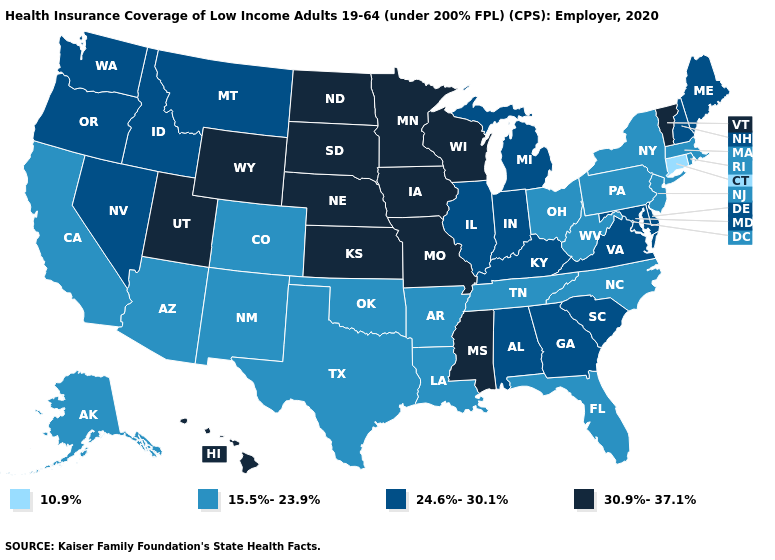Name the states that have a value in the range 15.5%-23.9%?
Quick response, please. Alaska, Arizona, Arkansas, California, Colorado, Florida, Louisiana, Massachusetts, New Jersey, New Mexico, New York, North Carolina, Ohio, Oklahoma, Pennsylvania, Rhode Island, Tennessee, Texas, West Virginia. Among the states that border Arkansas , does Texas have the highest value?
Quick response, please. No. Does Pennsylvania have the lowest value in the Northeast?
Concise answer only. No. What is the value of Alaska?
Write a very short answer. 15.5%-23.9%. What is the lowest value in the Northeast?
Quick response, please. 10.9%. Does the map have missing data?
Be succinct. No. Does Missouri have the highest value in the MidWest?
Keep it brief. Yes. Name the states that have a value in the range 30.9%-37.1%?
Quick response, please. Hawaii, Iowa, Kansas, Minnesota, Mississippi, Missouri, Nebraska, North Dakota, South Dakota, Utah, Vermont, Wisconsin, Wyoming. What is the lowest value in states that border Connecticut?
Give a very brief answer. 15.5%-23.9%. Name the states that have a value in the range 24.6%-30.1%?
Write a very short answer. Alabama, Delaware, Georgia, Idaho, Illinois, Indiana, Kentucky, Maine, Maryland, Michigan, Montana, Nevada, New Hampshire, Oregon, South Carolina, Virginia, Washington. Name the states that have a value in the range 15.5%-23.9%?
Be succinct. Alaska, Arizona, Arkansas, California, Colorado, Florida, Louisiana, Massachusetts, New Jersey, New Mexico, New York, North Carolina, Ohio, Oklahoma, Pennsylvania, Rhode Island, Tennessee, Texas, West Virginia. Which states have the lowest value in the South?
Write a very short answer. Arkansas, Florida, Louisiana, North Carolina, Oklahoma, Tennessee, Texas, West Virginia. Name the states that have a value in the range 24.6%-30.1%?
Write a very short answer. Alabama, Delaware, Georgia, Idaho, Illinois, Indiana, Kentucky, Maine, Maryland, Michigan, Montana, Nevada, New Hampshire, Oregon, South Carolina, Virginia, Washington. Does Tennessee have a higher value than Connecticut?
Be succinct. Yes. What is the highest value in the West ?
Be succinct. 30.9%-37.1%. 